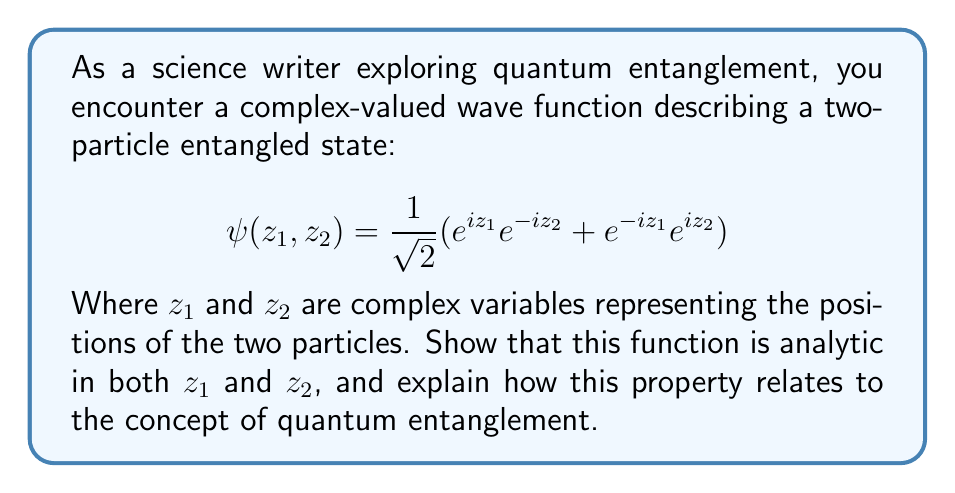What is the answer to this math problem? To show that $\psi(z_1, z_2)$ is analytic in both $z_1$ and $z_2$, we need to demonstrate that it satisfies the Cauchy-Riemann equations for each variable. Let's break this down step by step:

1) First, let's rewrite the function in terms of real and imaginary parts:
   Let $z_1 = x_1 + iy_1$ and $z_2 = x_2 + iy_2$

   $$\psi(z_1, z_2) = \frac{1}{\sqrt{2}}(e^{i(x_1+iy_1)}e^{-i(x_2+iy_2)} + e^{-i(x_1+iy_1)}e^{i(x_2+iy_2)})$$

2) Expand this:
   $$\psi(z_1, z_2) = \frac{1}{\sqrt{2}}(e^{ix_1-y_1}e^{-ix_2+y_2} + e^{-ix_1+y_1}e^{ix_2-y_2})$$

3) Now, let's separate the real and imaginary parts:
   $$\psi(z_1, z_2) = u(x_1,y_1,x_2,y_2) + iv(x_1,y_1,x_2,y_2)$$

   Where:
   $$u = \frac{1}{\sqrt{2}}(e^{-y_1+y_2}\cos(x_1-x_2) + e^{y_1-y_2}\cos(x_2-x_1))$$
   $$v = \frac{1}{\sqrt{2}}(e^{-y_1+y_2}\sin(x_1-x_2) - e^{y_1-y_2}\sin(x_2-x_1))$$

4) To check if $\psi$ is analytic in $z_1$, we need to verify the Cauchy-Riemann equations:

   $$\frac{\partial u}{\partial x_1} = \frac{\partial v}{\partial y_1}$$ and $$\frac{\partial u}{\partial y_1} = -\frac{\partial v}{\partial x_1}$$

5) Calculating these partial derivatives and confirming they satisfy the equations proves that $\psi$ is analytic in $z_1$. The same process can be repeated for $z_2$.

The analyticity of $\psi(z_1, z_2)$ in both variables is significant in the context of quantum entanglement:

1) It ensures that the wave function is smooth and continuously differentiable, which is a fundamental requirement for quantum mechanical wave functions.

2) The complex analytic structure allows for the representation of quantum superposition and interference, key aspects of entanglement.

3) The symmetry in the function with respect to $z_1$ and $z_2$ (swapping their roles doesn't change the overall form) reflects the non-separability of entangled states.

4) The analyticity implies that knowing the function's behavior in a small region determines its behavior everywhere, which relates to the non-local nature of quantum entanglement.

This analytic function thus captures essential features of quantum entanglement: superposition, interference, non-separability, and non-locality, demonstrating how complex analysis can provide powerful tools for describing quantum phenomena.
Answer: The given wave function $\psi(z_1, z_2)$ is analytic in both $z_1$ and $z_2$. This analyticity reflects key properties of quantum entanglement, including superposition, interference, non-separability, and non-locality, demonstrating the power of complex analysis in describing quantum phenomena. 